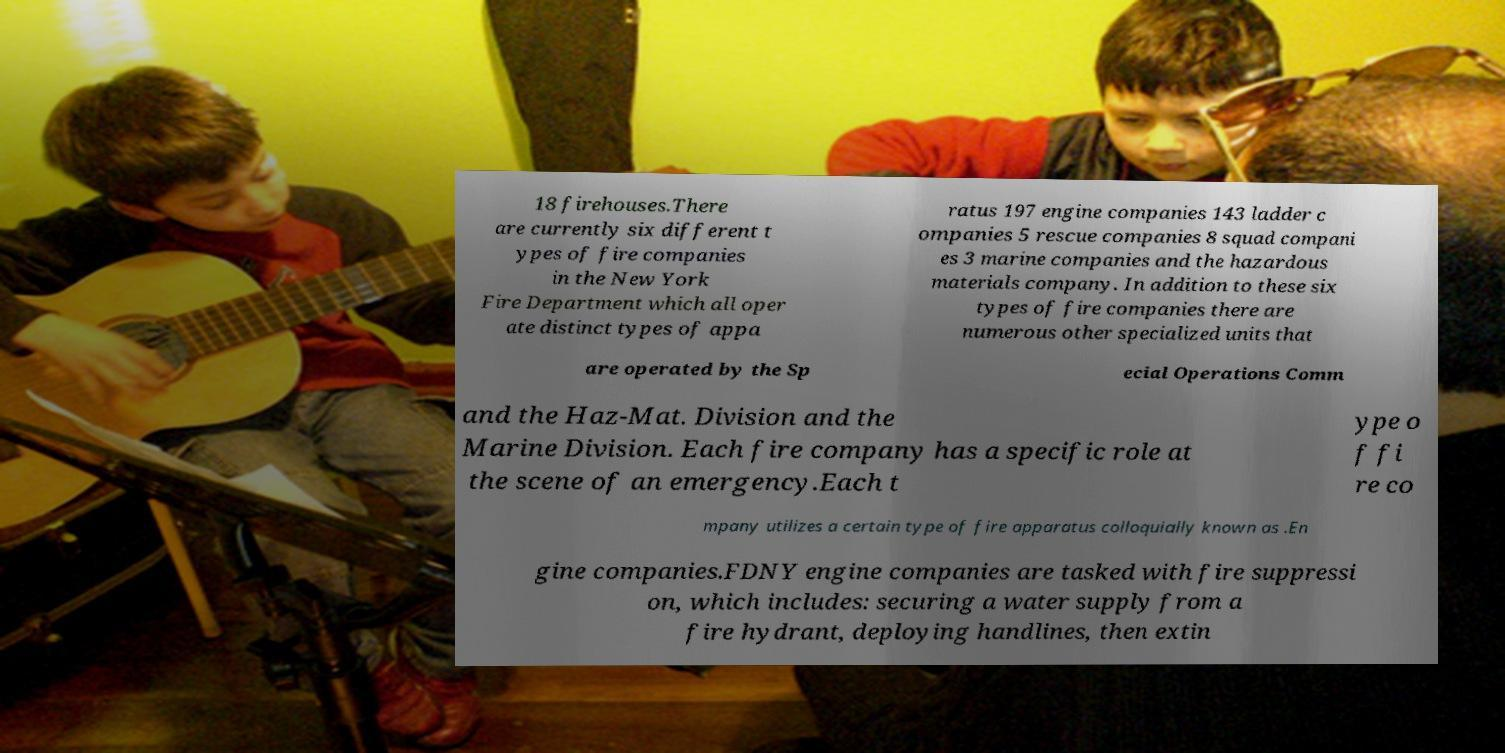There's text embedded in this image that I need extracted. Can you transcribe it verbatim? 18 firehouses.There are currently six different t ypes of fire companies in the New York Fire Department which all oper ate distinct types of appa ratus 197 engine companies 143 ladder c ompanies 5 rescue companies 8 squad compani es 3 marine companies and the hazardous materials company. In addition to these six types of fire companies there are numerous other specialized units that are operated by the Sp ecial Operations Comm and the Haz-Mat. Division and the Marine Division. Each fire company has a specific role at the scene of an emergency.Each t ype o f fi re co mpany utilizes a certain type of fire apparatus colloquially known as .En gine companies.FDNY engine companies are tasked with fire suppressi on, which includes: securing a water supply from a fire hydrant, deploying handlines, then extin 